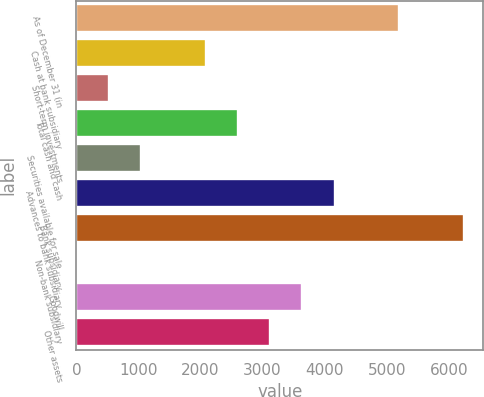Convert chart to OTSL. <chart><loc_0><loc_0><loc_500><loc_500><bar_chart><fcel>As of December 31 (in<fcel>Cash at bank subsidiary<fcel>Short-term investments<fcel>Total cash and cash<fcel>Securities available for sale<fcel>Advances to bank subsidiary<fcel>Bank subsidiary<fcel>Non-bank subsidiary<fcel>Goodwill<fcel>Other assets<nl><fcel>5201.3<fcel>2081.42<fcel>521.48<fcel>2601.4<fcel>1041.46<fcel>4161.34<fcel>6241.26<fcel>1.5<fcel>3641.36<fcel>3121.38<nl></chart> 